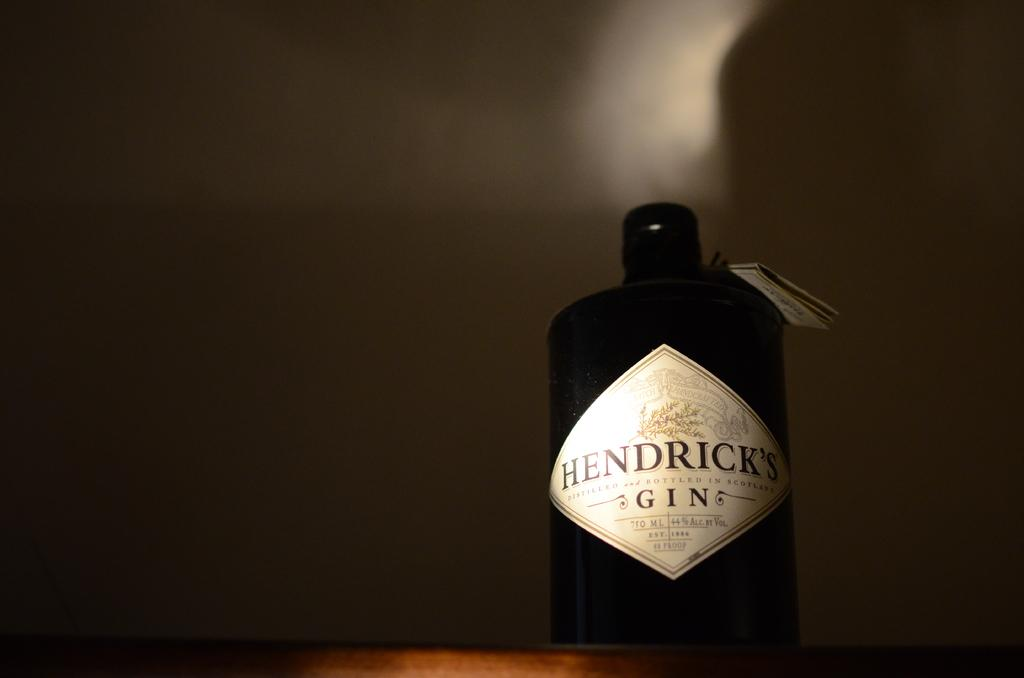<image>
Provide a brief description of the given image. A bottle of Hendrick's Gin in a dark room. 